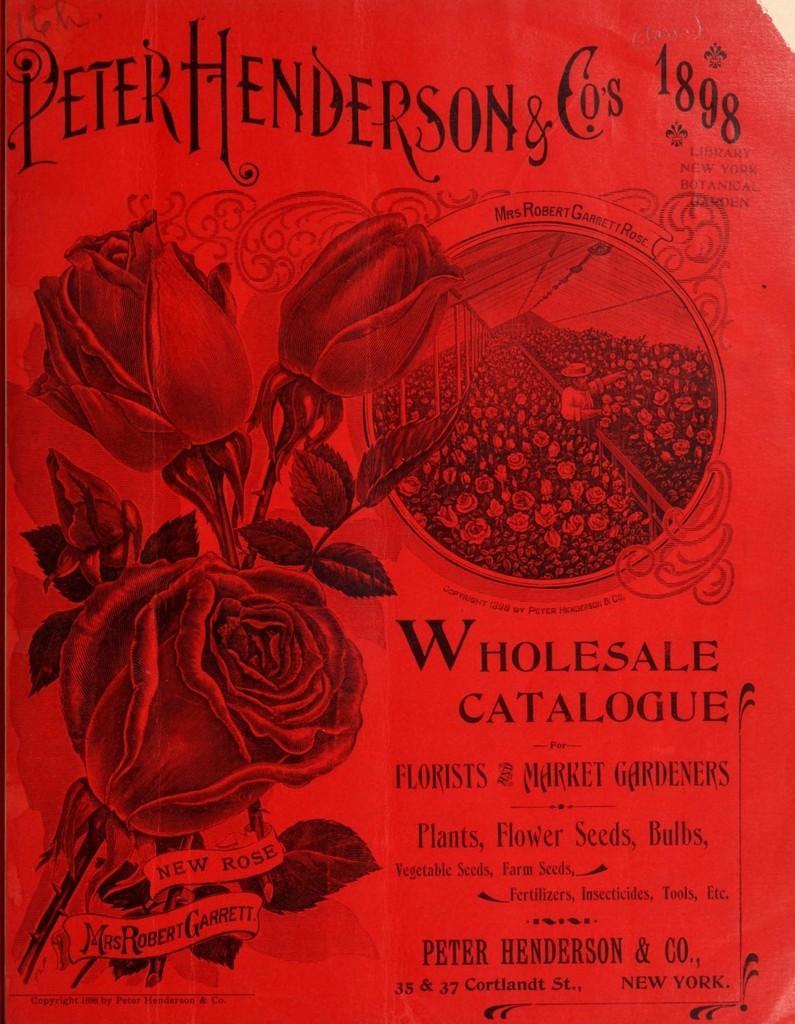Could you give a brief overview of what you see in this image? In the given object towards left side , I can see three roses and towards right there is a content which is written in the object.. 